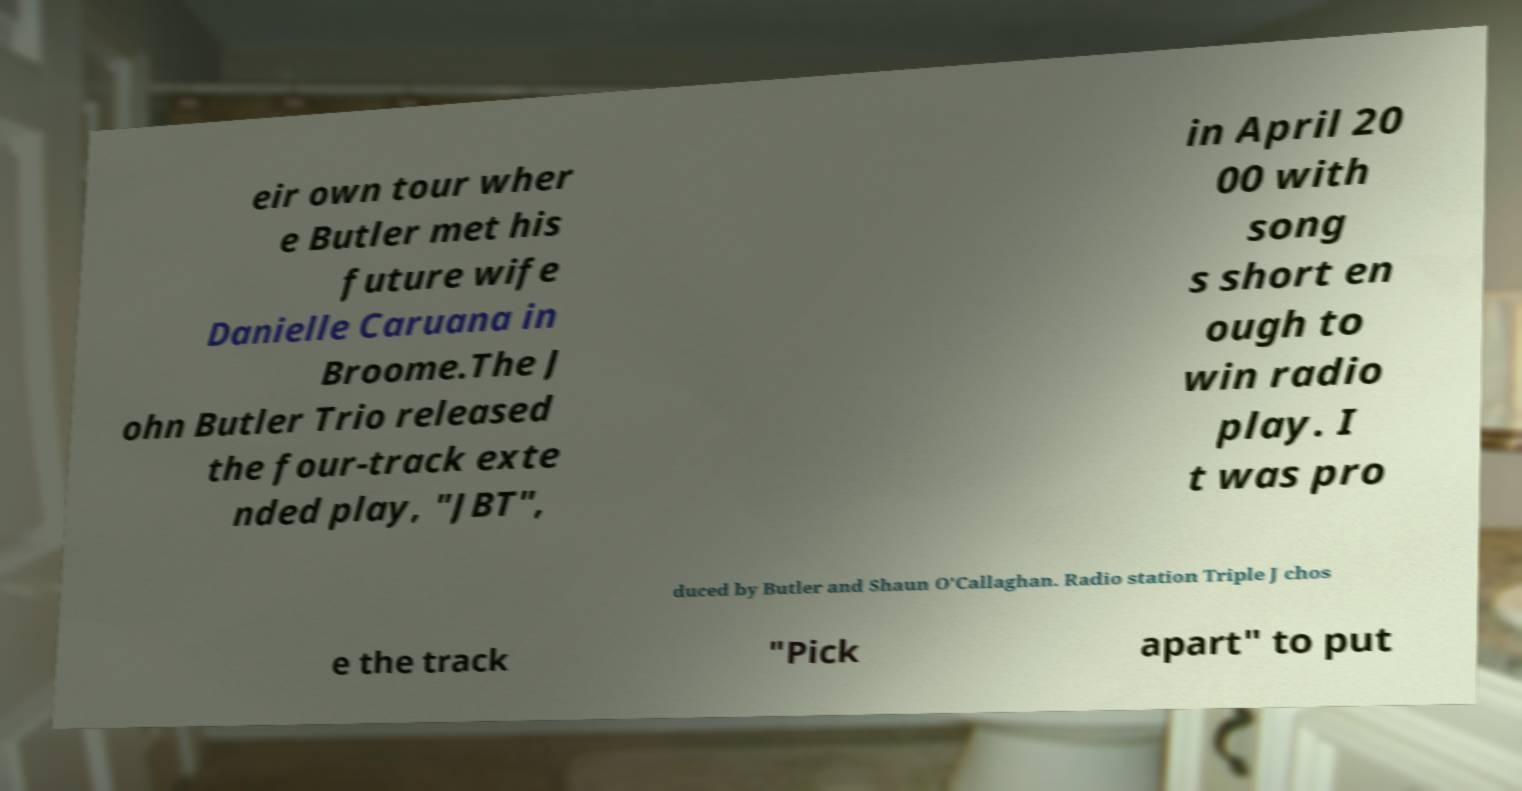Please identify and transcribe the text found in this image. eir own tour wher e Butler met his future wife Danielle Caruana in Broome.The J ohn Butler Trio released the four-track exte nded play, "JBT", in April 20 00 with song s short en ough to win radio play. I t was pro duced by Butler and Shaun O'Callaghan. Radio station Triple J chos e the track "Pick apart" to put 